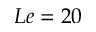Convert formula to latex. <formula><loc_0><loc_0><loc_500><loc_500>L e = 2 0</formula> 